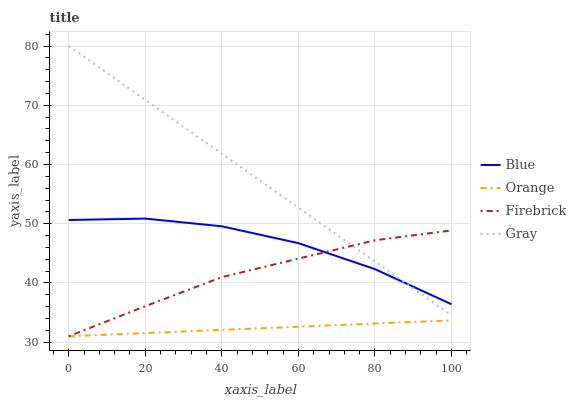Does Orange have the minimum area under the curve?
Answer yes or no. Yes. Does Gray have the maximum area under the curve?
Answer yes or no. Yes. Does Firebrick have the minimum area under the curve?
Answer yes or no. No. Does Firebrick have the maximum area under the curve?
Answer yes or no. No. Is Orange the smoothest?
Answer yes or no. Yes. Is Blue the roughest?
Answer yes or no. Yes. Is Firebrick the smoothest?
Answer yes or no. No. Is Firebrick the roughest?
Answer yes or no. No. Does Gray have the lowest value?
Answer yes or no. No. Does Gray have the highest value?
Answer yes or no. Yes. Does Firebrick have the highest value?
Answer yes or no. No. Is Orange less than Gray?
Answer yes or no. Yes. Is Blue greater than Orange?
Answer yes or no. Yes. Does Orange intersect Firebrick?
Answer yes or no. Yes. Is Orange less than Firebrick?
Answer yes or no. No. Is Orange greater than Firebrick?
Answer yes or no. No. Does Orange intersect Gray?
Answer yes or no. No. 